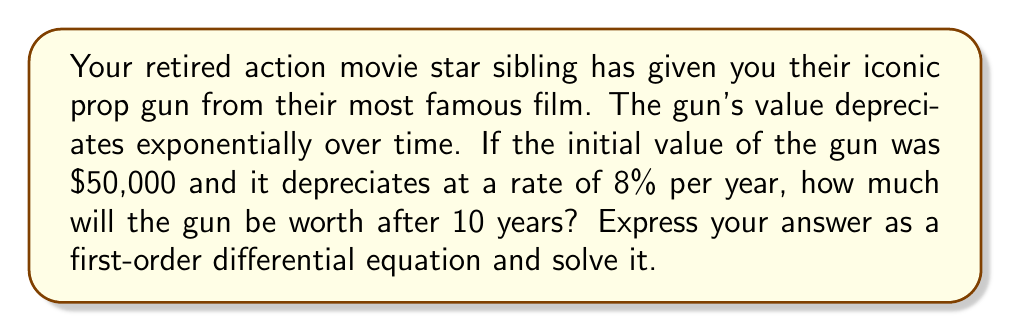What is the answer to this math problem? Let's approach this step-by-step:

1) Let $V(t)$ be the value of the gun at time $t$ (in years).

2) The rate of change of the gun's value is proportional to its current value. This can be expressed as:

   $$\frac{dV}{dt} = -kV$$

   where $k$ is the depreciation rate constant.

3) We're given that the depreciation rate is 8% per year. This means $k = 0.08$.

4) Our differential equation becomes:

   $$\frac{dV}{dt} = -0.08V$$

5) This is a separable first-order differential equation. We can solve it as follows:

   $$\frac{dV}{V} = -0.08dt$$

6) Integrating both sides:

   $$\int \frac{dV}{V} = \int -0.08dt$$
   $$\ln|V| = -0.08t + C$$

7) Taking the exponential of both sides:

   $$V = e^{-0.08t + C} = Ae^{-0.08t}$$

   where $A = e^C$ is a constant.

8) We can find $A$ using the initial condition: $V(0) = 50000$

   $$50000 = Ae^{-0.08(0)} = A$$

9) Therefore, our solution is:

   $$V(t) = 50000e^{-0.08t}$$

10) To find the value after 10 years, we substitute $t = 10$:

    $$V(10) = 50000e^{-0.08(10)} = 50000e^{-0.8} \approx 22465.18$$
Answer: The gun will be worth approximately $22,465.18 after 10 years. The first-order differential equation describing this depreciation is $\frac{dV}{dt} = -0.08V$ with the solution $V(t) = 50000e^{-0.08t}$. 